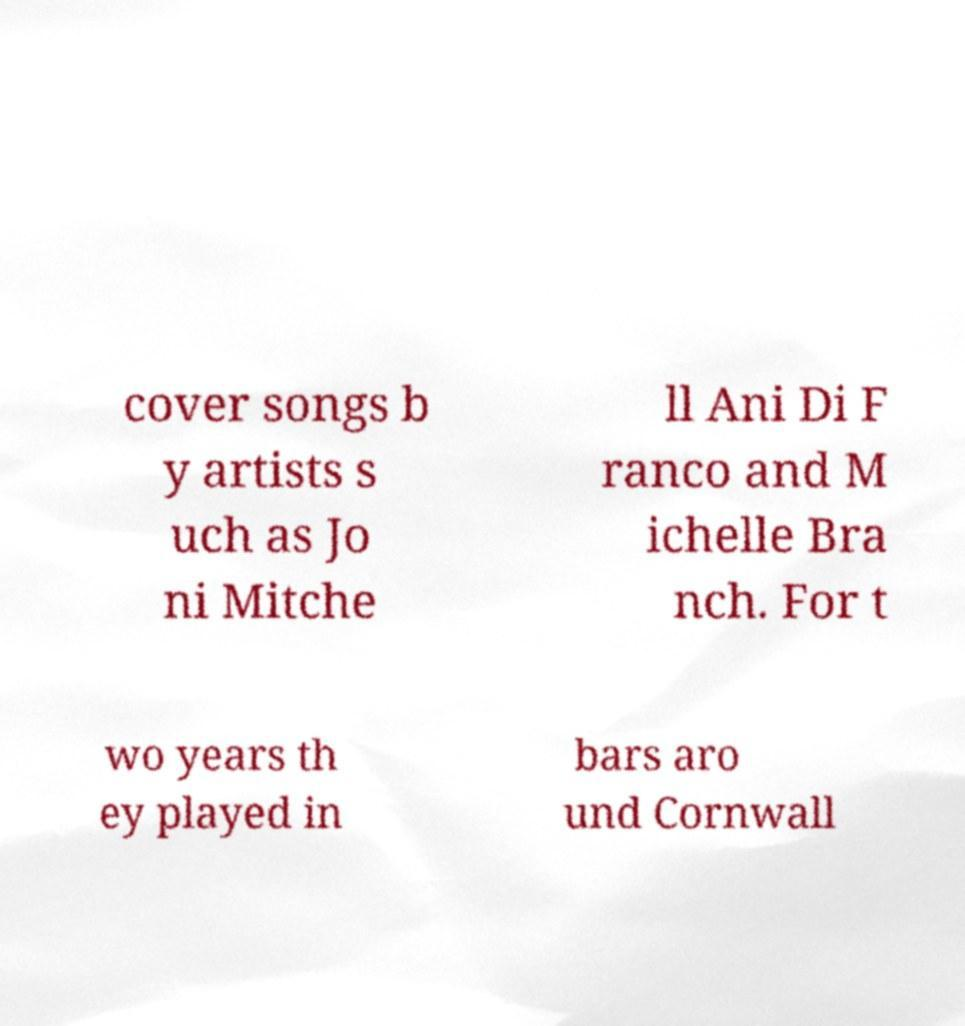Could you assist in decoding the text presented in this image and type it out clearly? cover songs b y artists s uch as Jo ni Mitche ll Ani Di F ranco and M ichelle Bra nch. For t wo years th ey played in bars aro und Cornwall 